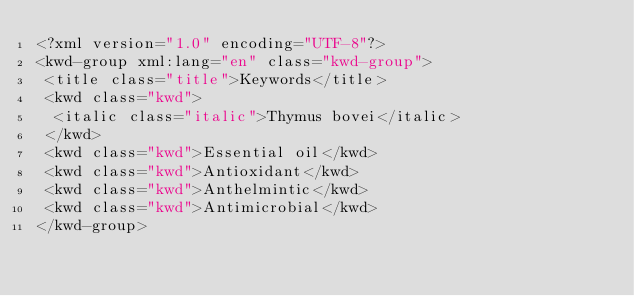<code> <loc_0><loc_0><loc_500><loc_500><_XML_><?xml version="1.0" encoding="UTF-8"?>
<kwd-group xml:lang="en" class="kwd-group">
 <title class="title">Keywords</title>
 <kwd class="kwd">
  <italic class="italic">Thymus bovei</italic>
 </kwd>
 <kwd class="kwd">Essential oil</kwd>
 <kwd class="kwd">Antioxidant</kwd>
 <kwd class="kwd">Anthelmintic</kwd>
 <kwd class="kwd">Antimicrobial</kwd>
</kwd-group>
</code> 